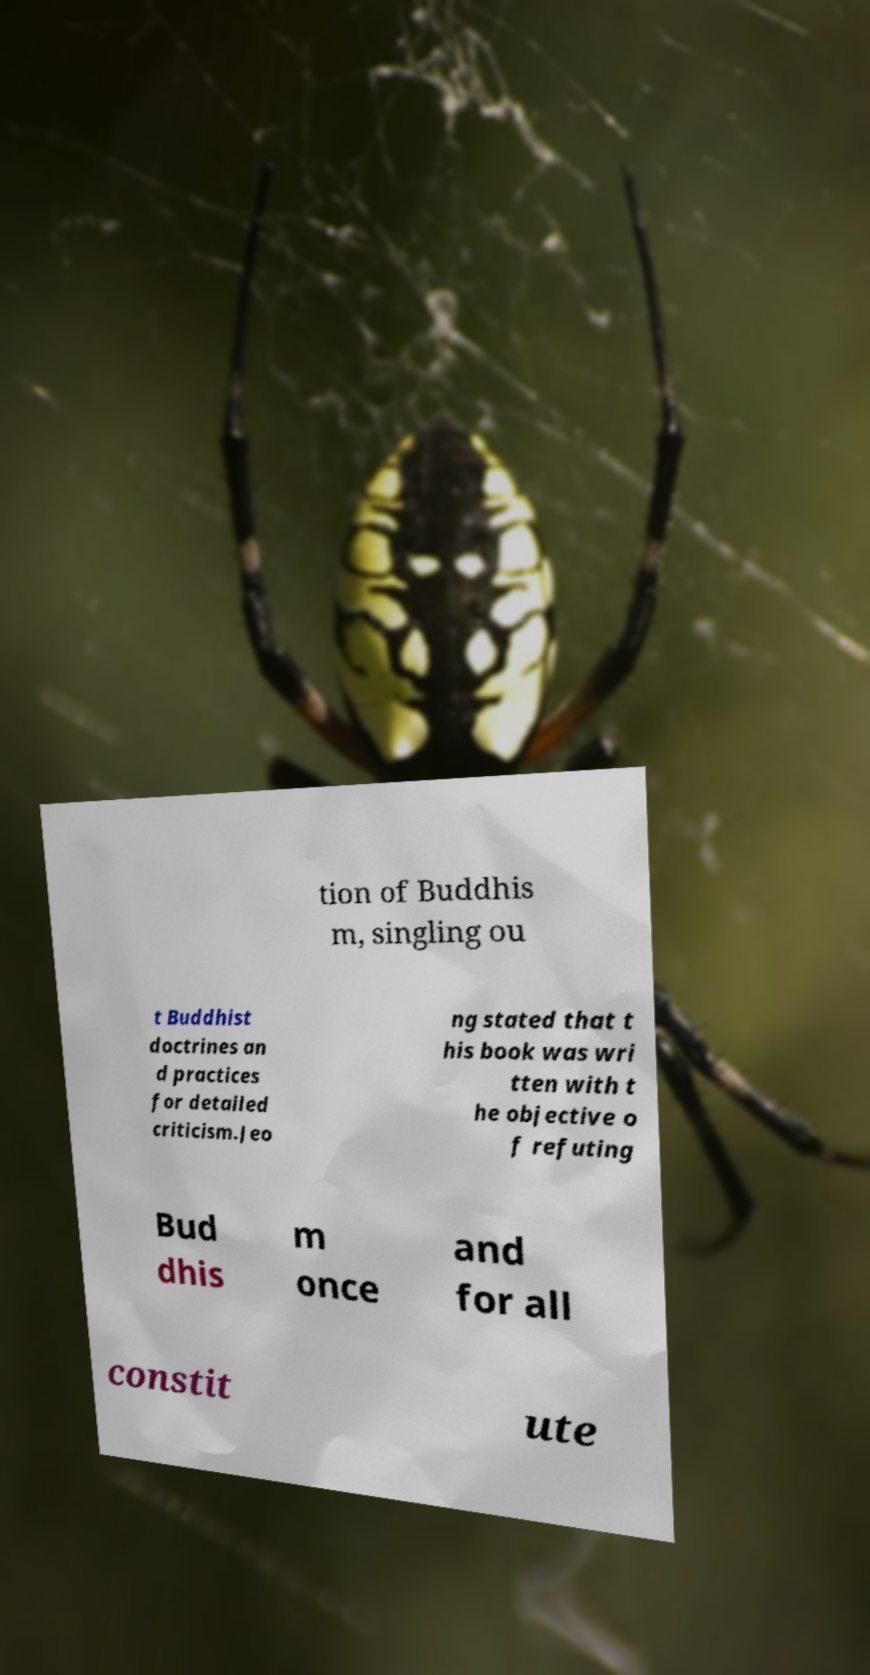For documentation purposes, I need the text within this image transcribed. Could you provide that? tion of Buddhis m, singling ou t Buddhist doctrines an d practices for detailed criticism.Jeo ng stated that t his book was wri tten with t he objective o f refuting Bud dhis m once and for all constit ute 